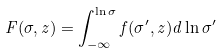Convert formula to latex. <formula><loc_0><loc_0><loc_500><loc_500>F ( \sigma , z ) = \int _ { - \infty } ^ { \ln \sigma } f ( \sigma ^ { \prime } , z ) d \ln \sigma ^ { \prime }</formula> 